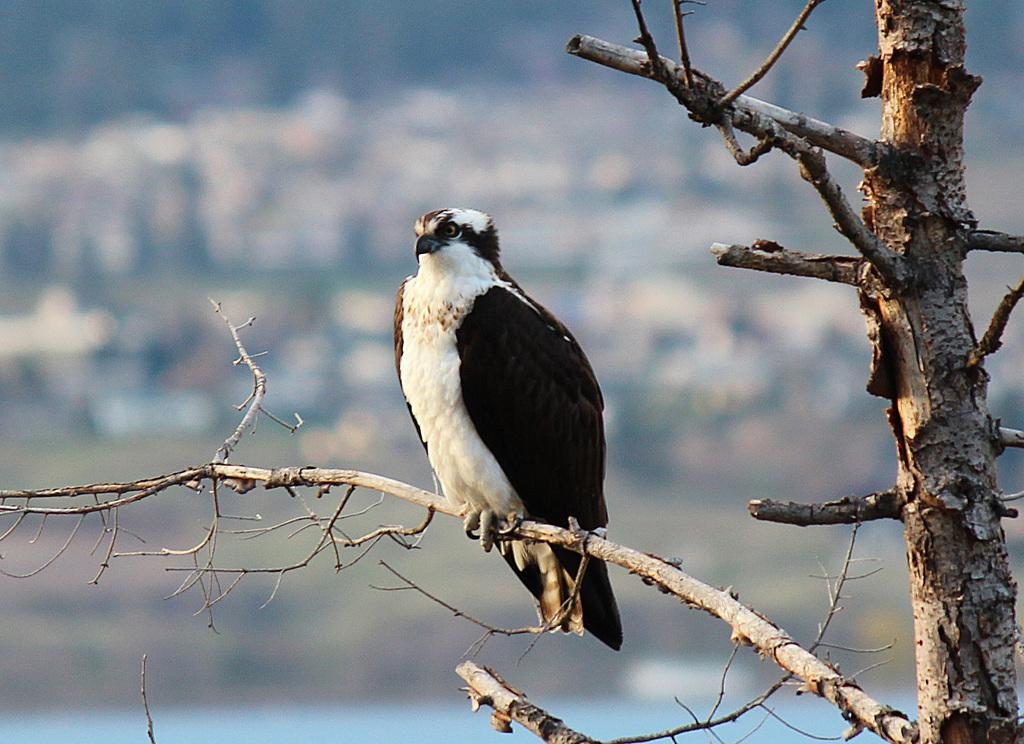What animal is featured in the image? There is an eagle in the image. Where is the eagle located in the image? The eagle is standing on a tree branch. What type of crate is visible in the image? There is no crate present in the image. What kind of creature is shown interacting with the eagle on the tree branch? There is no creature shown interacting with the eagle on the tree branch; only the eagle is present. 